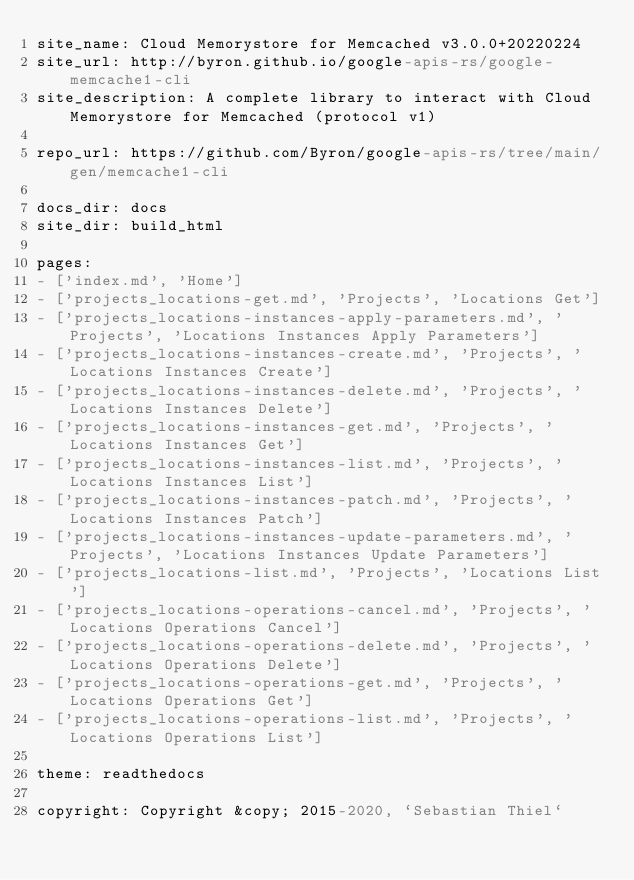<code> <loc_0><loc_0><loc_500><loc_500><_YAML_>site_name: Cloud Memorystore for Memcached v3.0.0+20220224
site_url: http://byron.github.io/google-apis-rs/google-memcache1-cli
site_description: A complete library to interact with Cloud Memorystore for Memcached (protocol v1)

repo_url: https://github.com/Byron/google-apis-rs/tree/main/gen/memcache1-cli

docs_dir: docs
site_dir: build_html

pages:
- ['index.md', 'Home']
- ['projects_locations-get.md', 'Projects', 'Locations Get']
- ['projects_locations-instances-apply-parameters.md', 'Projects', 'Locations Instances Apply Parameters']
- ['projects_locations-instances-create.md', 'Projects', 'Locations Instances Create']
- ['projects_locations-instances-delete.md', 'Projects', 'Locations Instances Delete']
- ['projects_locations-instances-get.md', 'Projects', 'Locations Instances Get']
- ['projects_locations-instances-list.md', 'Projects', 'Locations Instances List']
- ['projects_locations-instances-patch.md', 'Projects', 'Locations Instances Patch']
- ['projects_locations-instances-update-parameters.md', 'Projects', 'Locations Instances Update Parameters']
- ['projects_locations-list.md', 'Projects', 'Locations List']
- ['projects_locations-operations-cancel.md', 'Projects', 'Locations Operations Cancel']
- ['projects_locations-operations-delete.md', 'Projects', 'Locations Operations Delete']
- ['projects_locations-operations-get.md', 'Projects', 'Locations Operations Get']
- ['projects_locations-operations-list.md', 'Projects', 'Locations Operations List']

theme: readthedocs

copyright: Copyright &copy; 2015-2020, `Sebastian Thiel`

</code> 